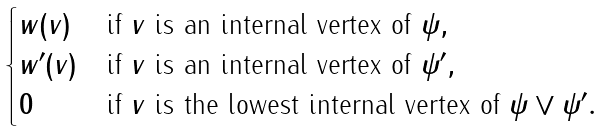Convert formula to latex. <formula><loc_0><loc_0><loc_500><loc_500>\begin{cases} w ( v ) & \text {if $v$ is an internal vertex of $\psi$} , \\ w ^ { \prime } ( v ) & \text {if $v$ is an internal vertex of $\psi^{\prime}$} , \\ 0 & \text {if $v$ is the lowest internal vertex of $\psi \vee \psi^{\prime}$} . \end{cases}</formula> 